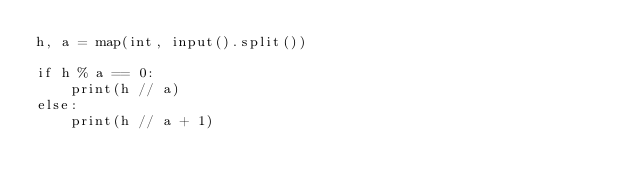Convert code to text. <code><loc_0><loc_0><loc_500><loc_500><_Python_>h, a = map(int, input().split())

if h % a == 0:
    print(h // a)
else:
    print(h // a + 1)
</code> 